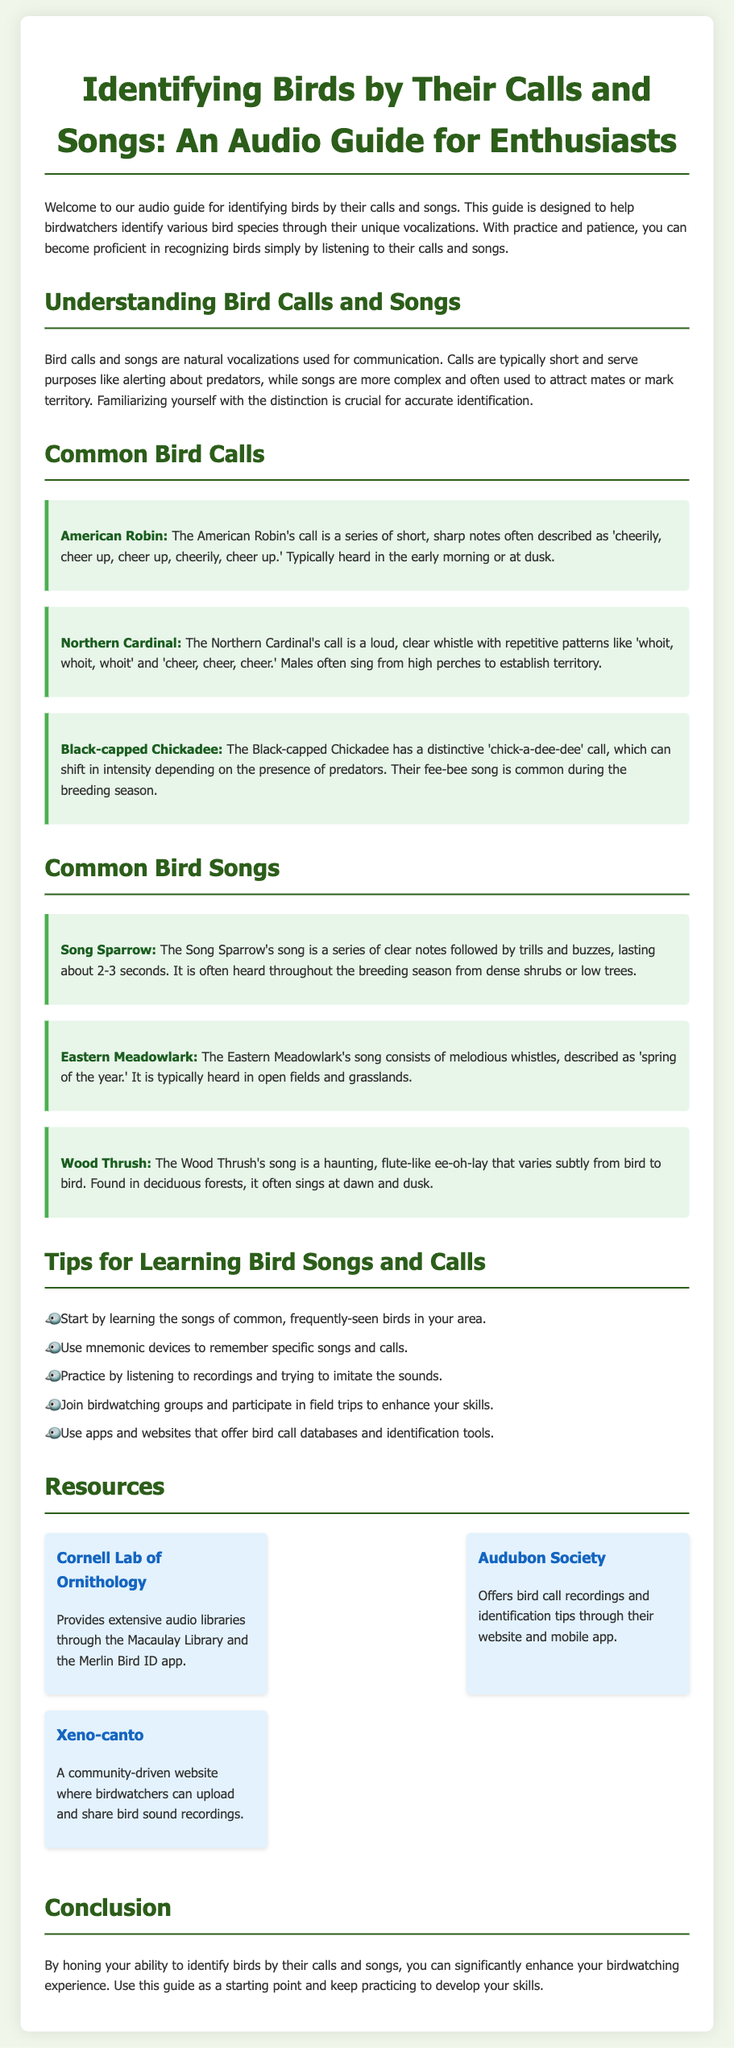what is the title of the guide? The title of the guide is stated at the top of the document.
Answer: Identifying Birds by Their Calls and Songs: An Audio Guide for Enthusiasts what is a characteristic of bird calls? The document describes bird calls and their purpose in communication.
Answer: Short vocalizations which bird's call is described as 'cheerily, cheer up'? The document provides specific descriptions of bird calls.
Answer: American Robin how long does a Song Sparrow's song typically last? The document states the duration of the Song Sparrow's song.
Answer: About 2-3 seconds what is the principal use of songs for birds? The guide distinguishes the functions of calls and songs for birds.
Answer: Attracting mates what bird is known for the 'chick-a-dee-dee' call? The document specifically mentions the call associated with this bird.
Answer: Black-capped Chickadee which resource provides extensive audio libraries? The document lists resources for learning more about bird calls and songs.
Answer: Cornell Lab of Ornithology how many tips are provided for learning bird songs and calls? The document details a list of tips for improving identification skills.
Answer: Five tips what type of website is Xeno-canto? The document describes the nature of this particular resource.
Answer: Community-driven website 